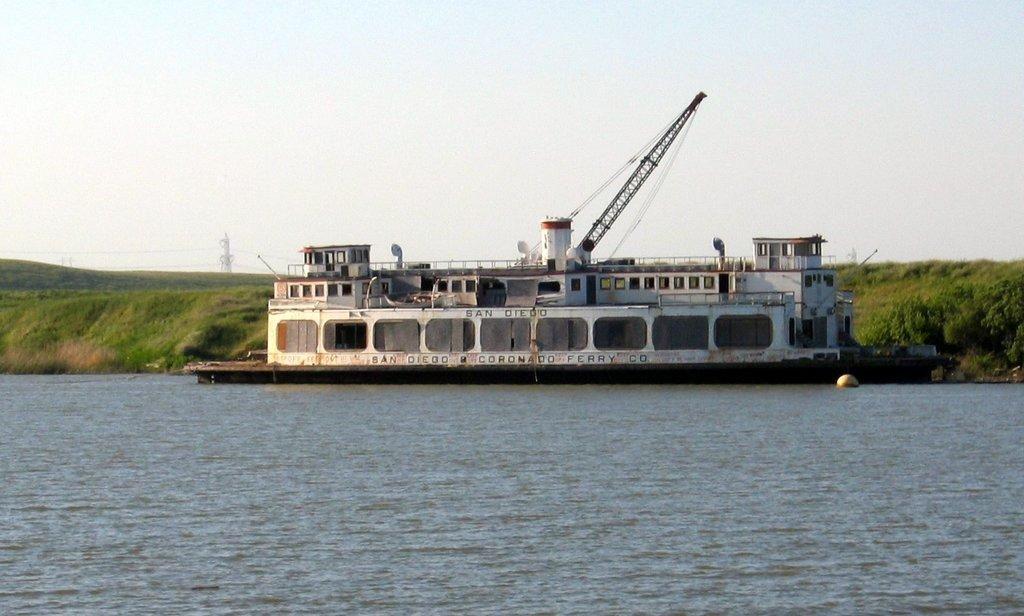What is the main feature of the image? There is water in the image. What is floating on the water? There is a white-colored boat on the water. What type of ground can be seen in the background? There is grass ground visible in the background. What structures are visible in the background? There is a tower in the background. What is visible above the water and structures? The sky is visible in the background. How many girls are playing near the volcano in the image? There is no volcano or girls present in the image. What type of quince is being used as a decoration on the boat? There is no quince present in the image, and the boat does not have any decorations. 